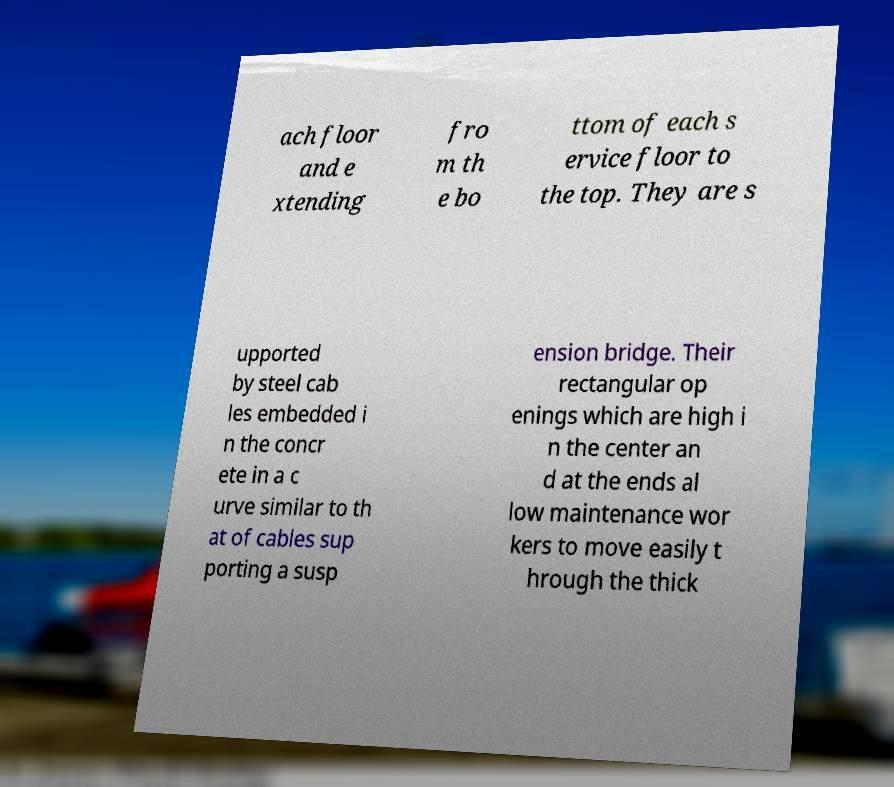There's text embedded in this image that I need extracted. Can you transcribe it verbatim? ach floor and e xtending fro m th e bo ttom of each s ervice floor to the top. They are s upported by steel cab les embedded i n the concr ete in a c urve similar to th at of cables sup porting a susp ension bridge. Their rectangular op enings which are high i n the center an d at the ends al low maintenance wor kers to move easily t hrough the thick 